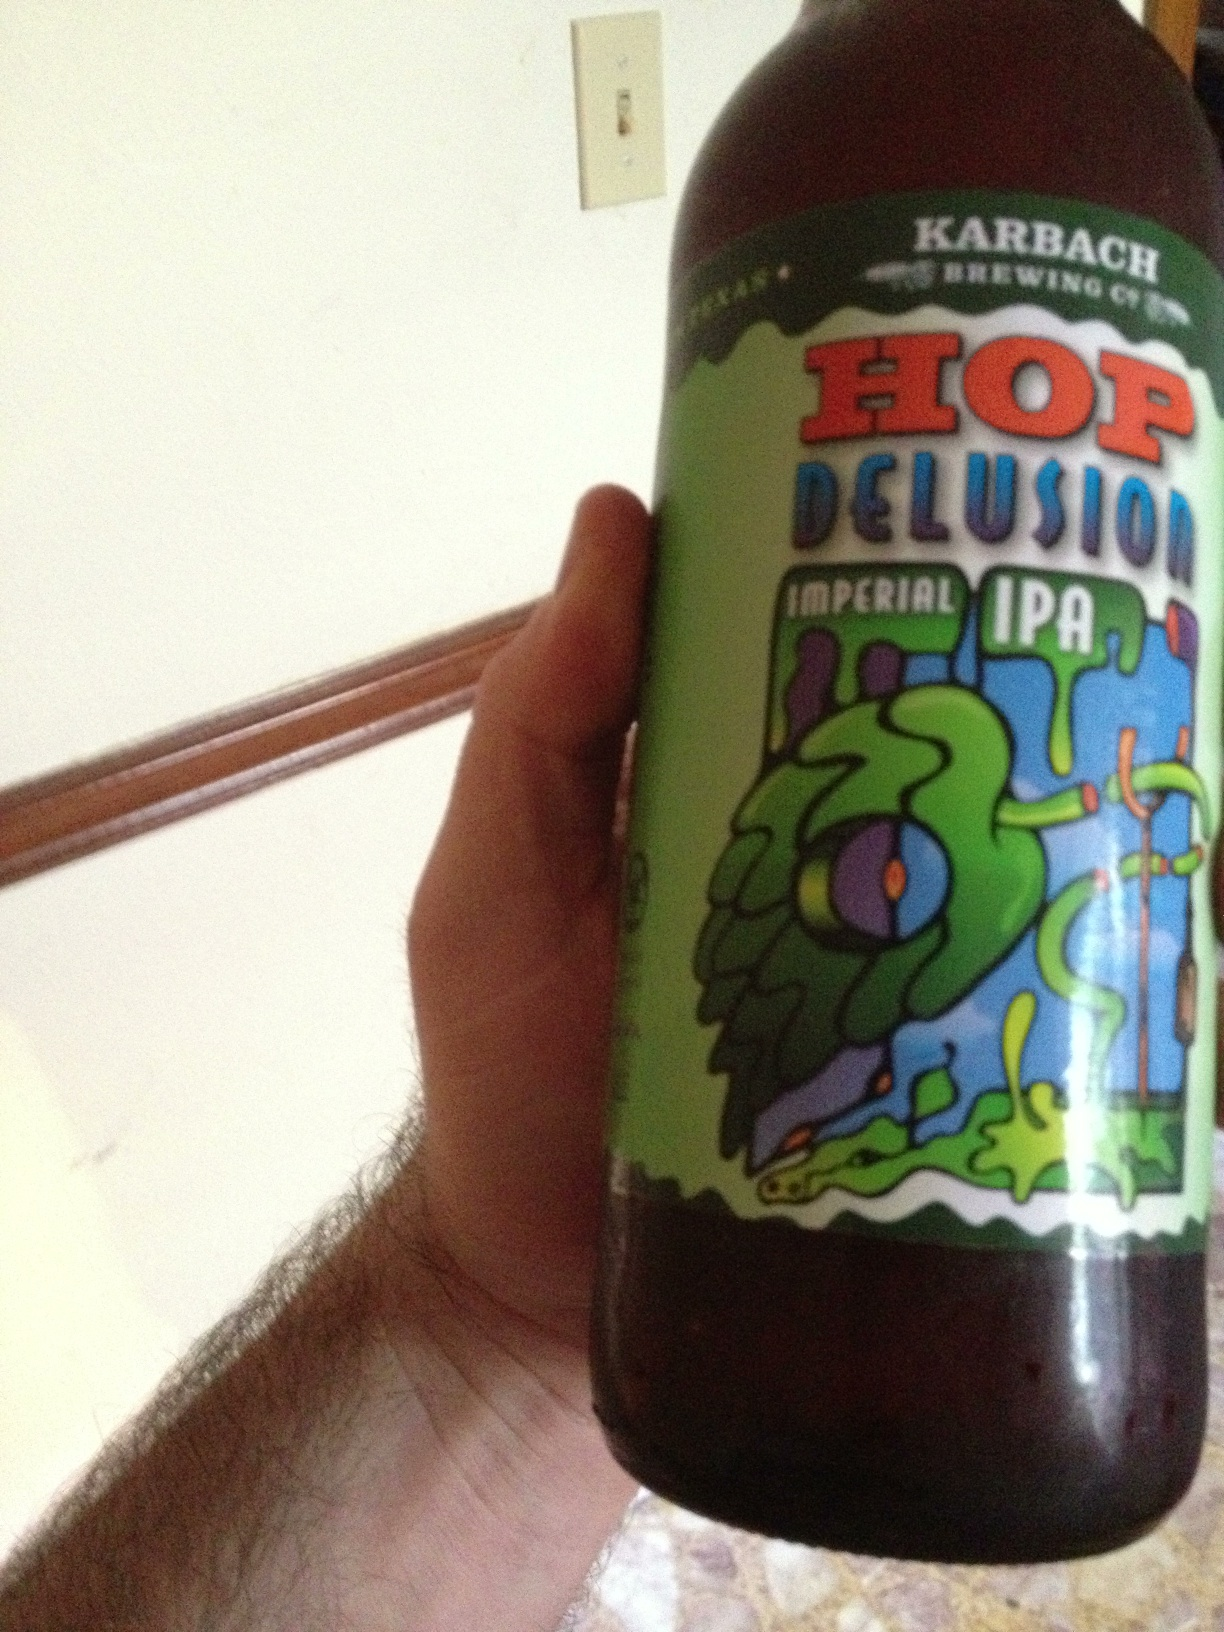What's a memorable story about someone experiencing this beer for the first time? A beer enthusiast once visited a local brew festival where Karbach Brewing Co. had a stand. Intrigued by the colorful label of Hop Delusion Imperial IPA, they decided to give it a try. Upon the first sip, they were taken aback by the intense yet balanced flavors, a wonderful mix of bitterness and malty sweetness. It was love at first taste, leading them to delve deeper into the world of craft beers and even start brewing their own. 